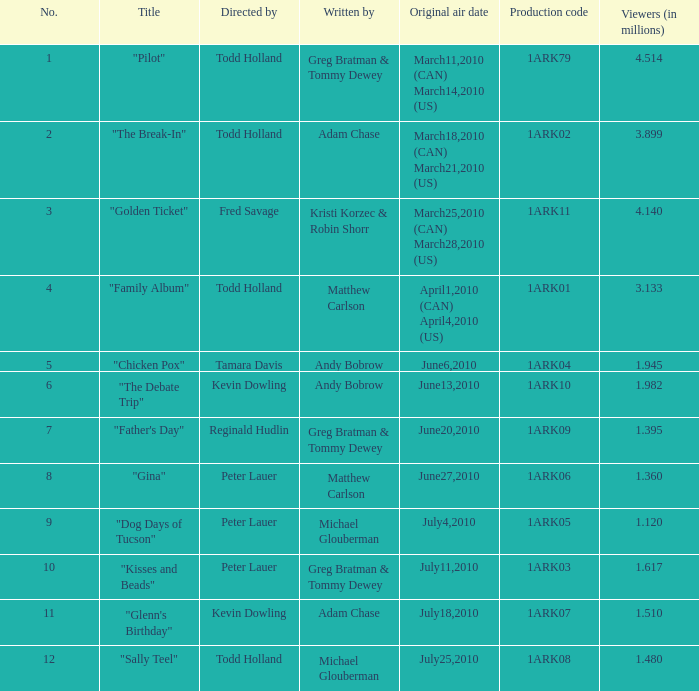What is the first broadcast date for production code 1ark79? March11,2010 (CAN) March14,2010 (US). 